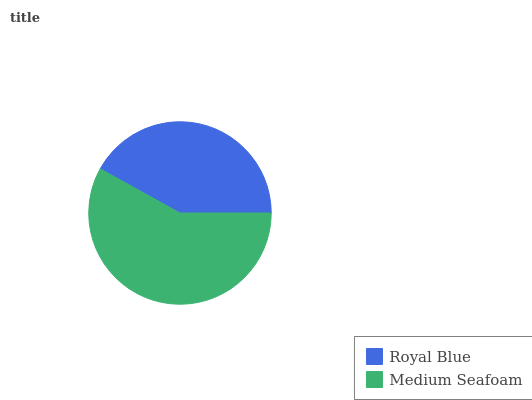Is Royal Blue the minimum?
Answer yes or no. Yes. Is Medium Seafoam the maximum?
Answer yes or no. Yes. Is Medium Seafoam the minimum?
Answer yes or no. No. Is Medium Seafoam greater than Royal Blue?
Answer yes or no. Yes. Is Royal Blue less than Medium Seafoam?
Answer yes or no. Yes. Is Royal Blue greater than Medium Seafoam?
Answer yes or no. No. Is Medium Seafoam less than Royal Blue?
Answer yes or no. No. Is Medium Seafoam the high median?
Answer yes or no. Yes. Is Royal Blue the low median?
Answer yes or no. Yes. Is Royal Blue the high median?
Answer yes or no. No. Is Medium Seafoam the low median?
Answer yes or no. No. 